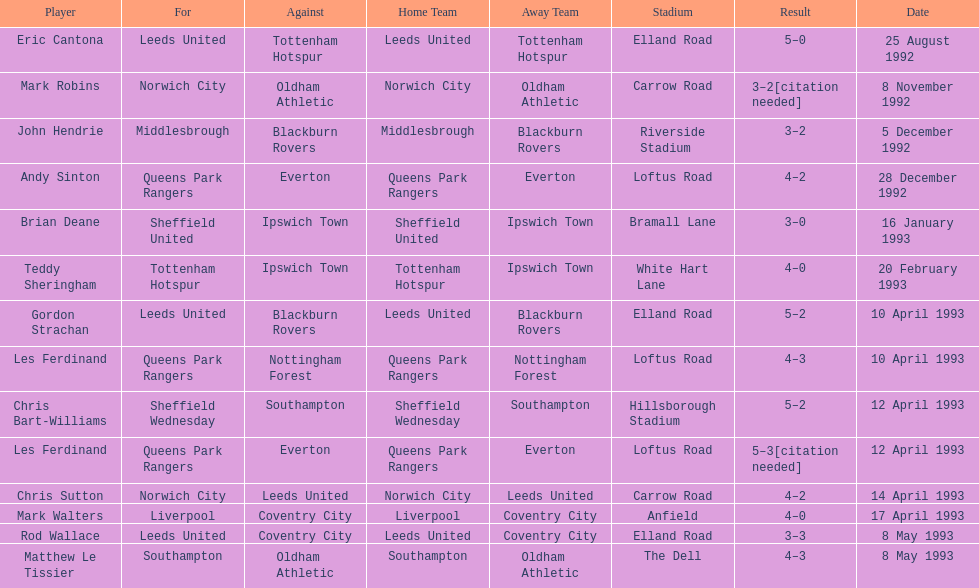Southampton had a match on may 8th, 1993 - who were they up against? Oldham Athletic. 